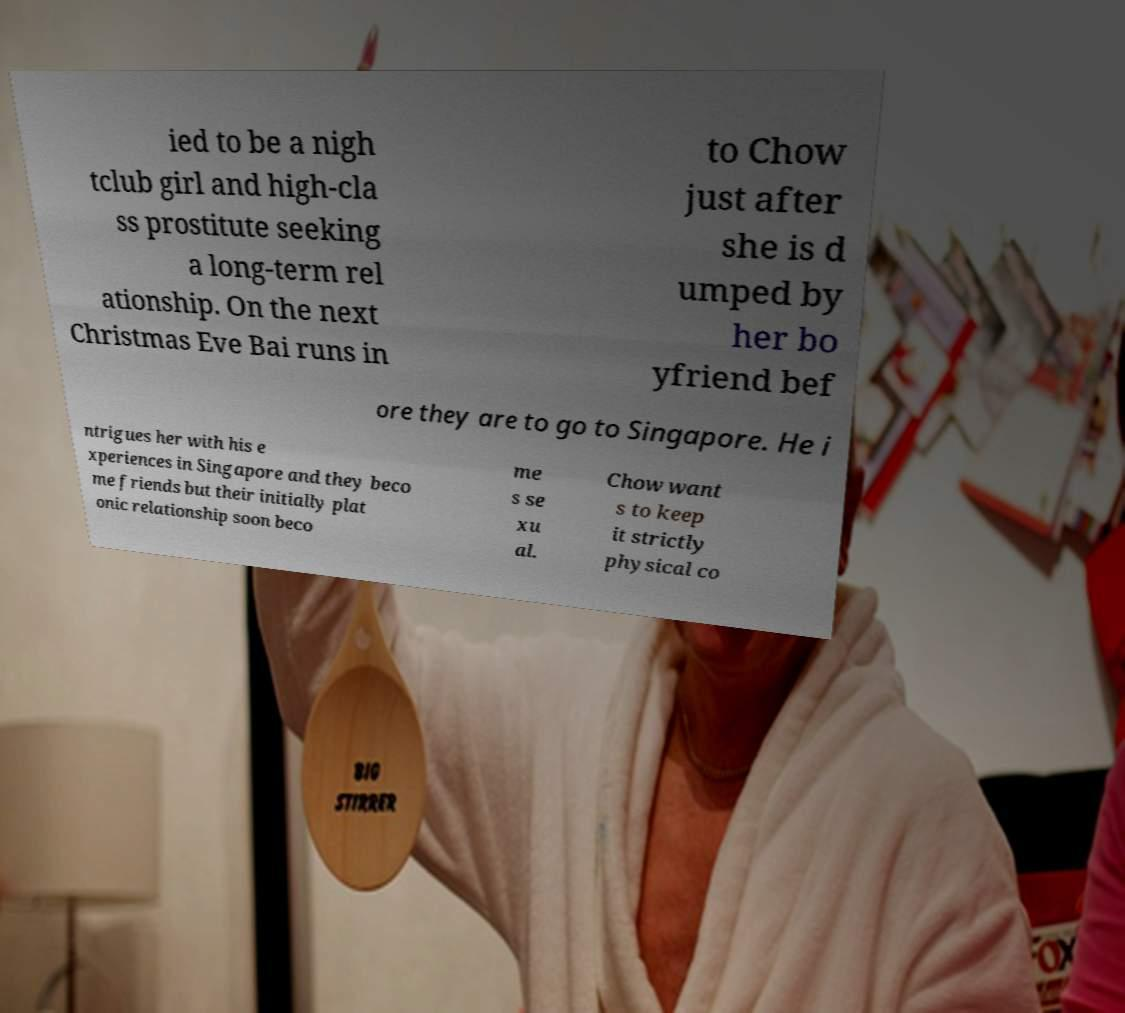Can you read and provide the text displayed in the image?This photo seems to have some interesting text. Can you extract and type it out for me? ied to be a nigh tclub girl and high-cla ss prostitute seeking a long-term rel ationship. On the next Christmas Eve Bai runs in to Chow just after she is d umped by her bo yfriend bef ore they are to go to Singapore. He i ntrigues her with his e xperiences in Singapore and they beco me friends but their initially plat onic relationship soon beco me s se xu al. Chow want s to keep it strictly physical co 